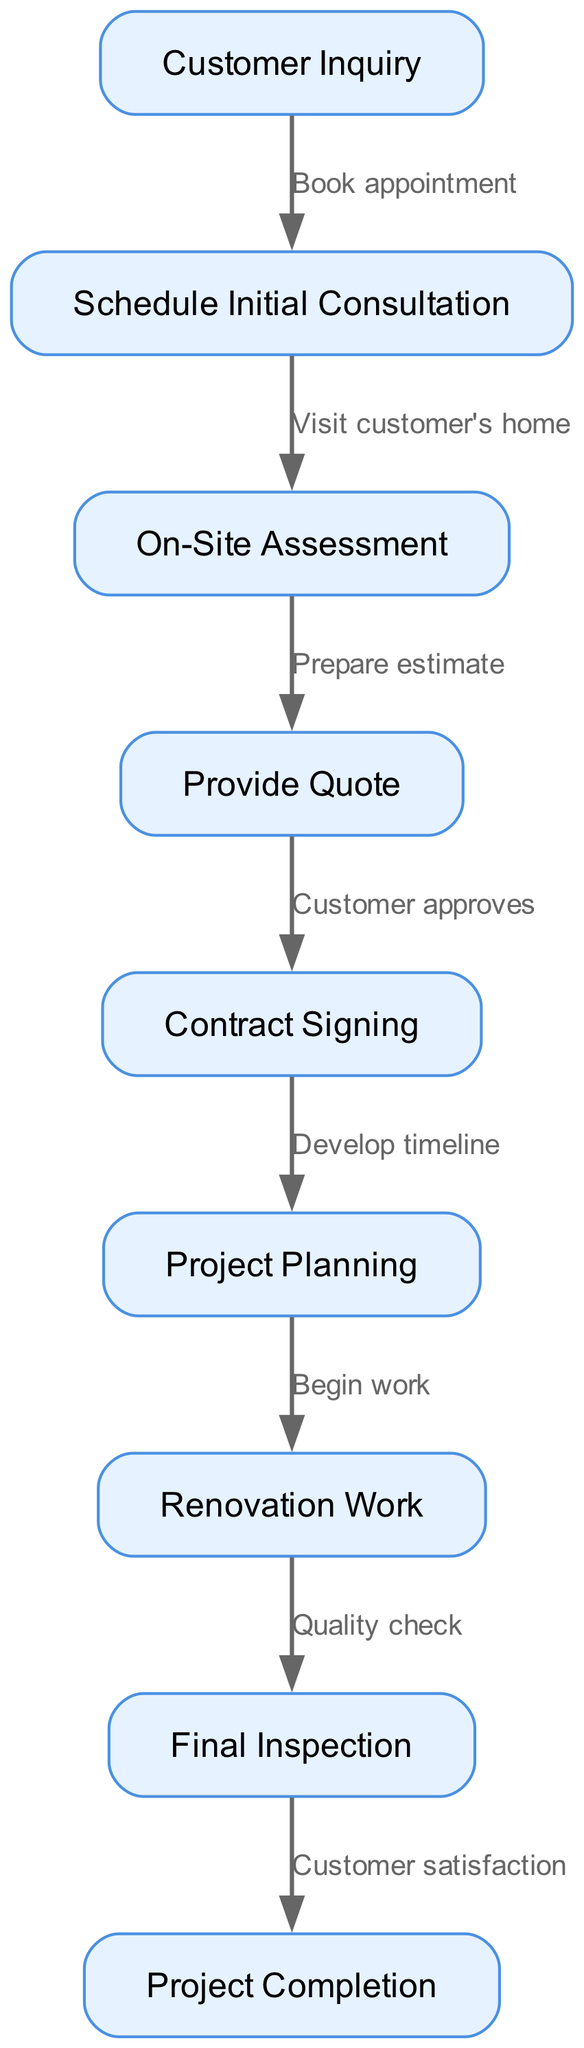What is the first step in the customer service process? The first step in the process is represented by the node labeled "Customer Inquiry," which indicates the starting point of customer interaction.
Answer: Customer Inquiry How many nodes are in the diagram? The diagram displays a total of 9 nodes, each representing a distinct step in the customer service process.
Answer: 9 What is the last step before "Project Completion"? The last step leading to "Project Completion" is "Final Inspection," which shows that this step occurs just before the project's completion stage.
Answer: Final Inspection What happens after "Contract Signing"? After "Contract Signing," the next step is "Project Planning," indicating that the planning phase occurs following the signing of the contract.
Answer: Project Planning What is the relationship between "On-Site Assessment" and "Provide Quote"? "On-Site Assessment" leads to "Provide Quote," meaning that after conducting the assessment at the customer's location, a quote is prepared for the customer.
Answer: Prepare estimate What is the total number of edges in the diagram? The diagram contains 8 edges, representing the connections between different steps in the customer service process.
Answer: 8 How does "Customer Inquiry" relate to "Schedule Initial Consultation"? The relationship is that the customer must book an appointment to schedule the initial consultation following their inquiry. This connection reflects the flow from the customer's first interaction to scheduling a meeting.
Answer: Book appointment Which step involves assessing the customer's home? The "On-Site Assessment" step is specifically focused on evaluating the condition or needs of the customer's home before providing a quote.
Answer: On-Site Assessment Which step indicates the need for a quality check? The "Quality check" occurs after the actual "Renovation Work," indicating that completion of the renovation is followed by verifying its quality.
Answer: Quality check 